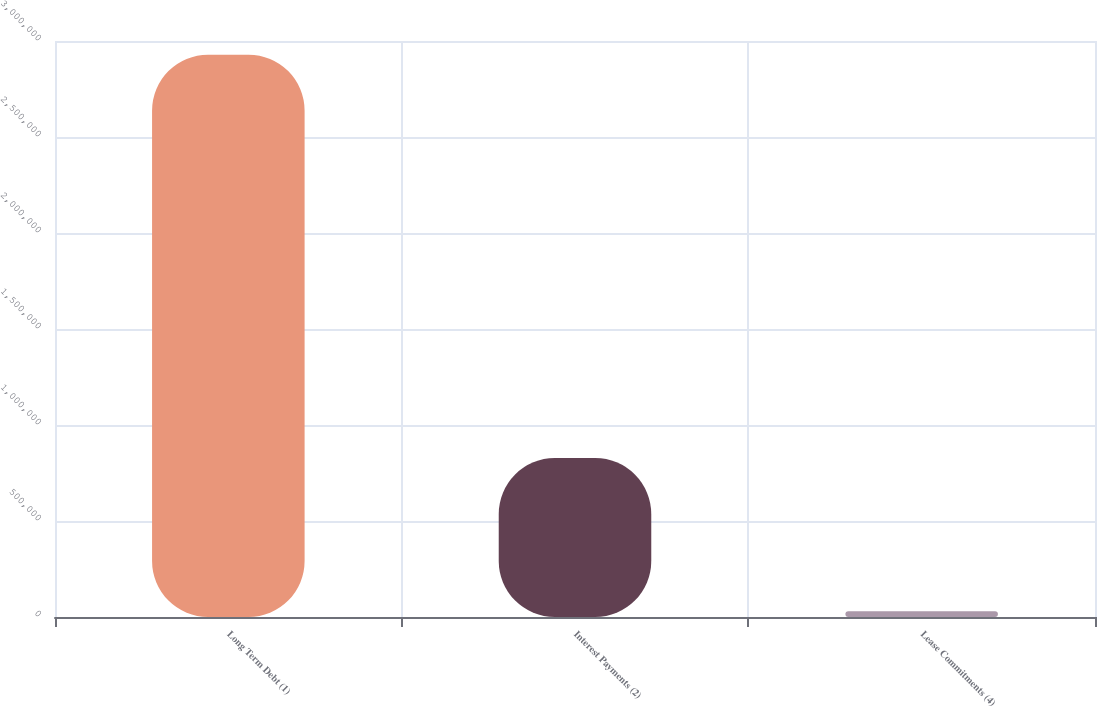Convert chart. <chart><loc_0><loc_0><loc_500><loc_500><bar_chart><fcel>Long Term Debt (1)<fcel>Interest Payments (2)<fcel>Lease Commitments (4)<nl><fcel>2.92858e+06<fcel>827835<fcel>30474<nl></chart> 